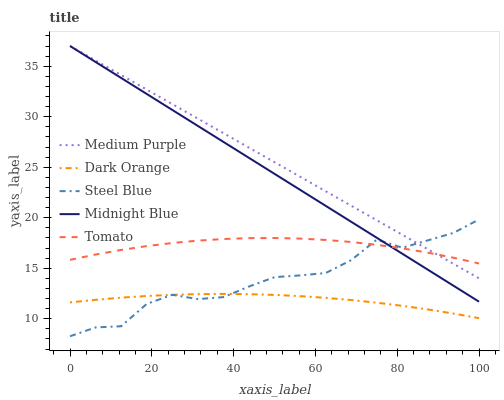Does Dark Orange have the minimum area under the curve?
Answer yes or no. Yes. Does Medium Purple have the maximum area under the curve?
Answer yes or no. Yes. Does Tomato have the minimum area under the curve?
Answer yes or no. No. Does Tomato have the maximum area under the curve?
Answer yes or no. No. Is Midnight Blue the smoothest?
Answer yes or no. Yes. Is Steel Blue the roughest?
Answer yes or no. Yes. Is Dark Orange the smoothest?
Answer yes or no. No. Is Dark Orange the roughest?
Answer yes or no. No. Does Steel Blue have the lowest value?
Answer yes or no. Yes. Does Dark Orange have the lowest value?
Answer yes or no. No. Does Midnight Blue have the highest value?
Answer yes or no. Yes. Does Tomato have the highest value?
Answer yes or no. No. Is Dark Orange less than Medium Purple?
Answer yes or no. Yes. Is Tomato greater than Dark Orange?
Answer yes or no. Yes. Does Steel Blue intersect Midnight Blue?
Answer yes or no. Yes. Is Steel Blue less than Midnight Blue?
Answer yes or no. No. Is Steel Blue greater than Midnight Blue?
Answer yes or no. No. Does Dark Orange intersect Medium Purple?
Answer yes or no. No. 